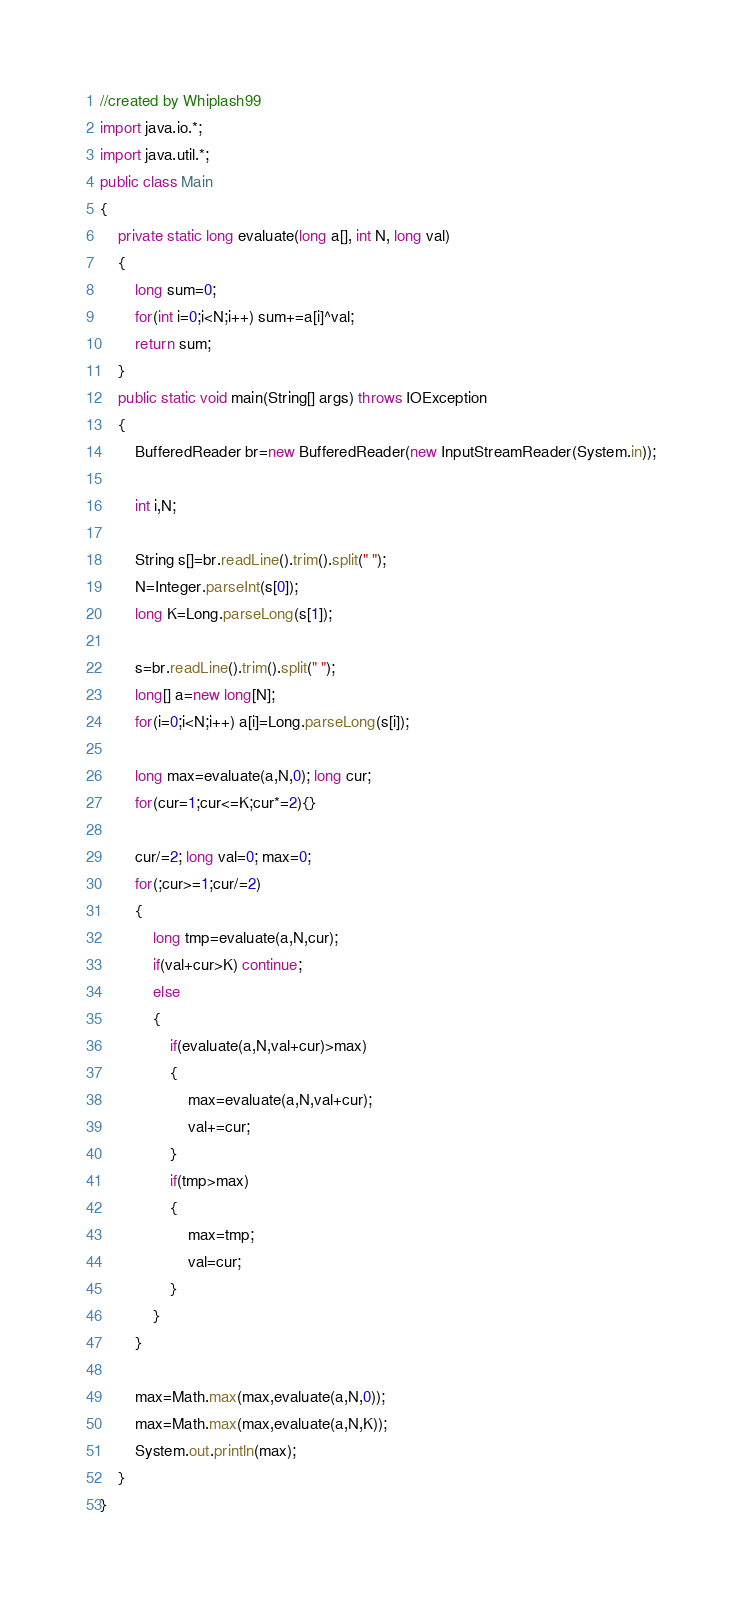Convert code to text. <code><loc_0><loc_0><loc_500><loc_500><_Java_>//created by Whiplash99
import java.io.*;
import java.util.*;
public class Main
{
    private static long evaluate(long a[], int N, long val)
    {
        long sum=0;
        for(int i=0;i<N;i++) sum+=a[i]^val;
        return sum;
    }
    public static void main(String[] args) throws IOException
    {
        BufferedReader br=new BufferedReader(new InputStreamReader(System.in));

        int i,N;

        String s[]=br.readLine().trim().split(" ");
        N=Integer.parseInt(s[0]);
        long K=Long.parseLong(s[1]);

        s=br.readLine().trim().split(" ");
        long[] a=new long[N];
        for(i=0;i<N;i++) a[i]=Long.parseLong(s[i]);

        long max=evaluate(a,N,0); long cur;
        for(cur=1;cur<=K;cur*=2){}

        cur/=2; long val=0; max=0;
        for(;cur>=1;cur/=2)
        {
            long tmp=evaluate(a,N,cur);
            if(val+cur>K) continue;
            else
            {
                if(evaluate(a,N,val+cur)>max)
                {
                    max=evaluate(a,N,val+cur);
                    val+=cur;
                }
                if(tmp>max)
                {
                    max=tmp;
                    val=cur;
                }
            }
        }

        max=Math.max(max,evaluate(a,N,0));
        max=Math.max(max,evaluate(a,N,K));
        System.out.println(max);
    }
}</code> 